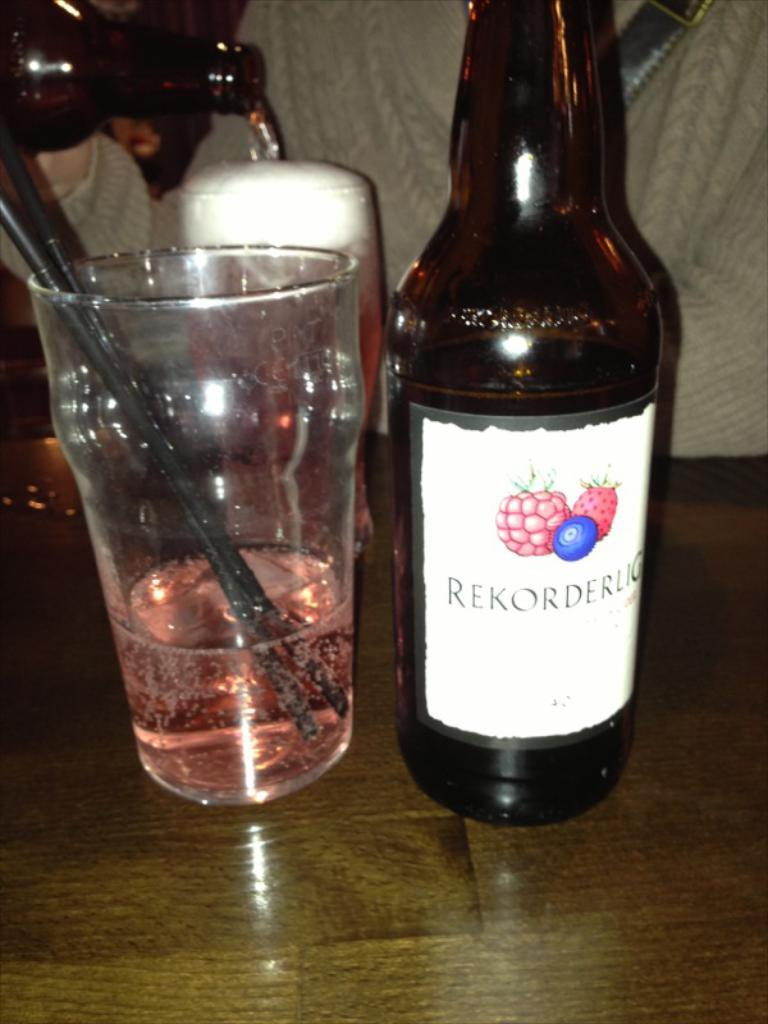<image>
Render a clear and concise summary of the photo. a bottle of Rekorderog is sitting by a glass of pink liquid 